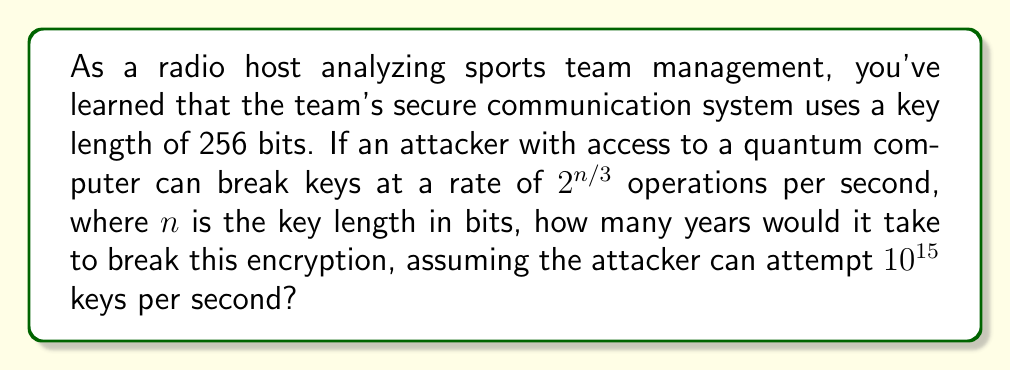Give your solution to this math problem. Let's approach this step-by-step:

1) The key length is 256 bits, so $n = 256$.

2) The attacker can break keys at a rate of $2^{n/3}$ operations per second.
   Substituting $n = 256$, we get $2^{256/3} = 2^{85.33}$ operations.

3) The attacker can attempt $10^{15}$ keys per second.

4) To find the time needed, we divide the number of operations by the attempts per second:
   
   $T = \frac{2^{85.33}}{10^{15}}$ seconds

5) Let's calculate this:
   $2^{85.33} \approx 3.83 \times 10^{25}$
   
   So, $T = \frac{3.83 \times 10^{25}}{10^{15}} = 3.83 \times 10^{10}$ seconds

6) To convert this to years, we divide by seconds in a year:
   Seconds in a year = 365.25 * 24 * 60 * 60 = 31,557,600
   
   Years = $\frac{3.83 \times 10^{10}}{31,557,600} \approx 1,213.97$ years

Therefore, it would take approximately 1,214 years to break this encryption.
Answer: 1,214 years 